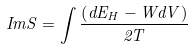Convert formula to latex. <formula><loc_0><loc_0><loc_500><loc_500>I m S = \int \frac { \left ( d E _ { H } - W d V \right ) } { 2 T }</formula> 